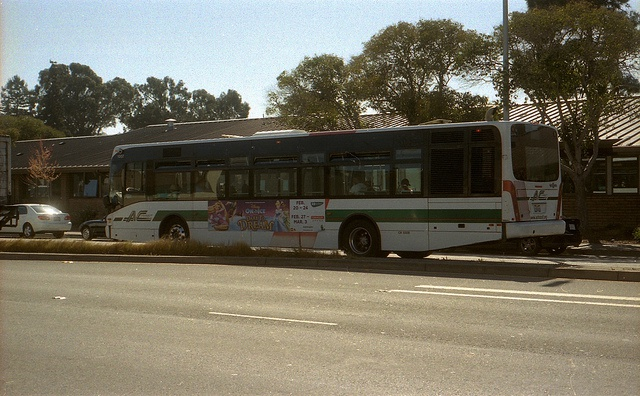Describe the objects in this image and their specific colors. I can see bus in darkgray, black, and gray tones, car in darkgray, black, and gray tones, car in darkgray, gray, black, and ivory tones, car in darkgray, black, and gray tones, and people in darkgray and black tones in this image. 